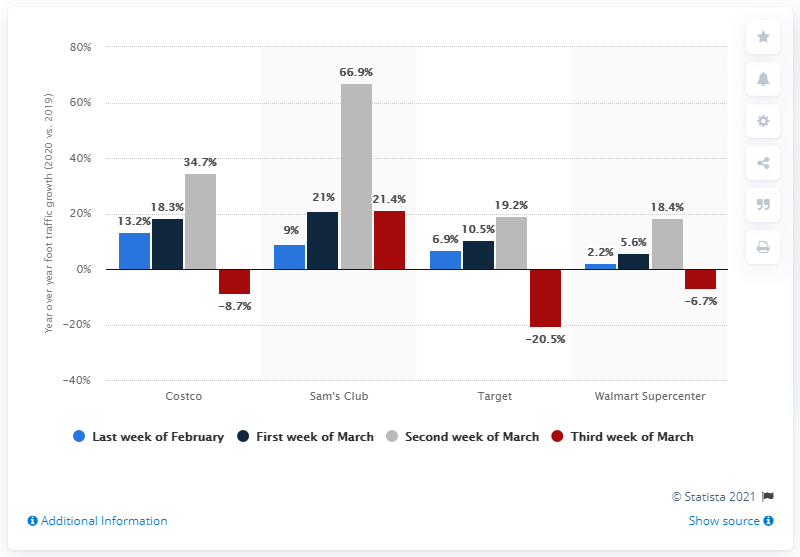Specify some key components in this picture. According to data collected in the second week of March 2020, foot traffic at Sam's Club stores increased by 66.9% compared to the previous week. 